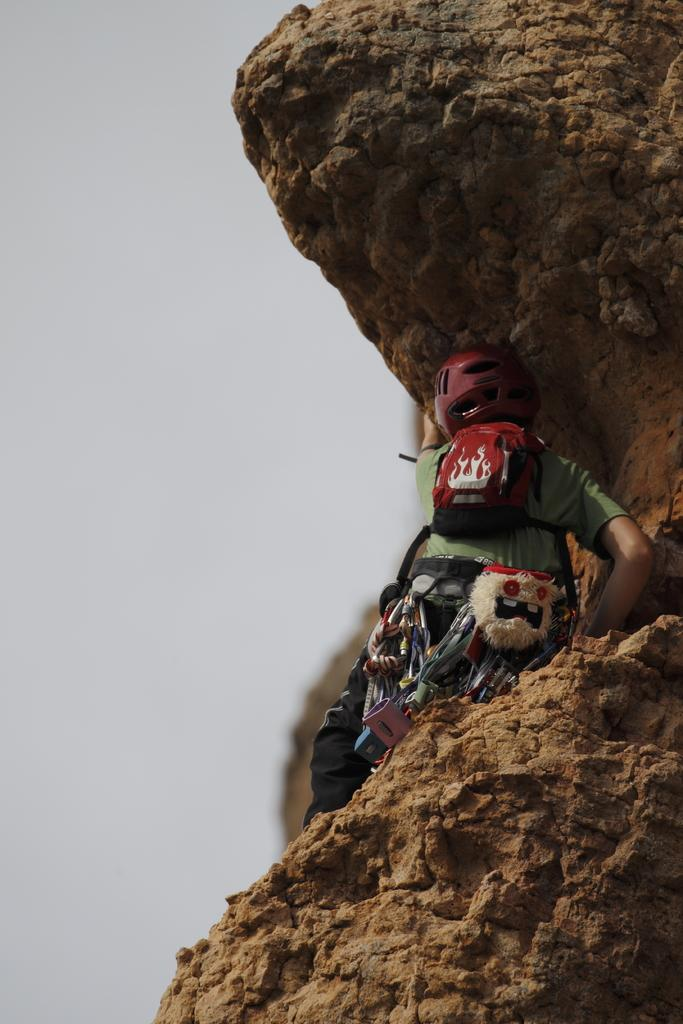What is the main subject of the image? There is a person in the image. What is the person doing in the image? The person is climbing a rock. What is the person carrying while climbing the rock? The person is carrying a bag. What safety gear is the person wearing in the image? The person is wearing a helmet. What can be seen on the left side of the image? The sky is visible on the left side of the image. What type of yam is the person holding in the image? There is no yam present in the image; the person is climbing a rock and carrying a bag. How many books can be seen in the image? There are no books visible in the image. 